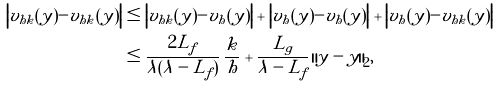<formula> <loc_0><loc_0><loc_500><loc_500>\left | v _ { h k } ( y ) - v _ { h k } ( \tilde { y } ) \right | & \leq \left | v _ { h k } ( y ) - v _ { h } ( y ) \right | + \left | v _ { h } ( y ) - v _ { h } ( \tilde { y } ) \right | + \left | v _ { h } ( \tilde { y } ) - v _ { h k } ( \tilde { y } ) \right | \\ & \leq \frac { 2 L _ { f } } { \lambda ( \lambda - L _ { f } ) } \, \frac { k } { h } + \frac { L _ { g } } { \lambda - L _ { f } } \, { \| y - \tilde { y } \| } _ { 2 } ,</formula> 